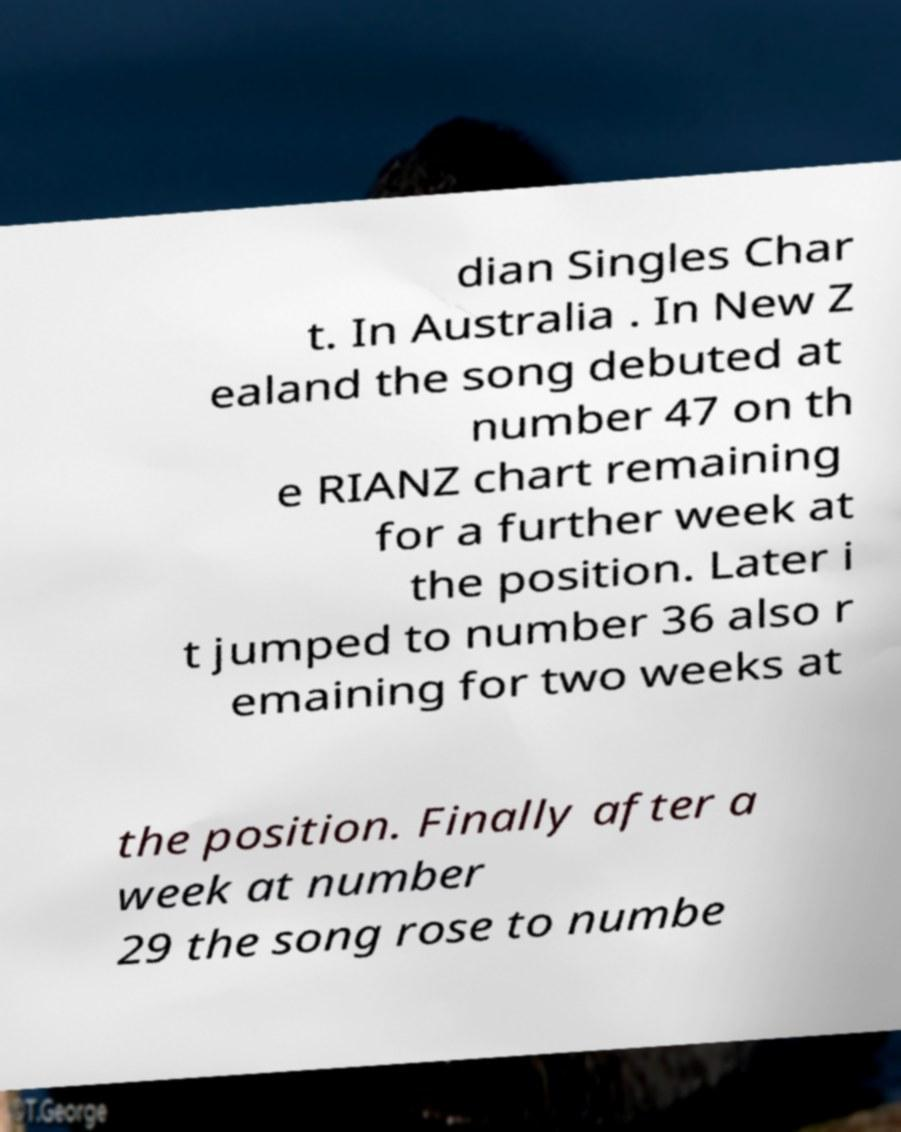Can you accurately transcribe the text from the provided image for me? dian Singles Char t. In Australia . In New Z ealand the song debuted at number 47 on th e RIANZ chart remaining for a further week at the position. Later i t jumped to number 36 also r emaining for two weeks at the position. Finally after a week at number 29 the song rose to numbe 